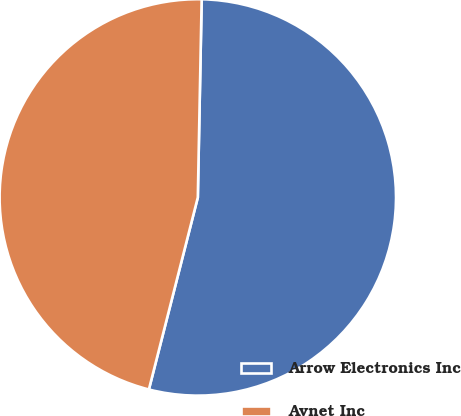Convert chart. <chart><loc_0><loc_0><loc_500><loc_500><pie_chart><fcel>Arrow Electronics Inc<fcel>Avnet Inc<nl><fcel>53.66%<fcel>46.34%<nl></chart> 